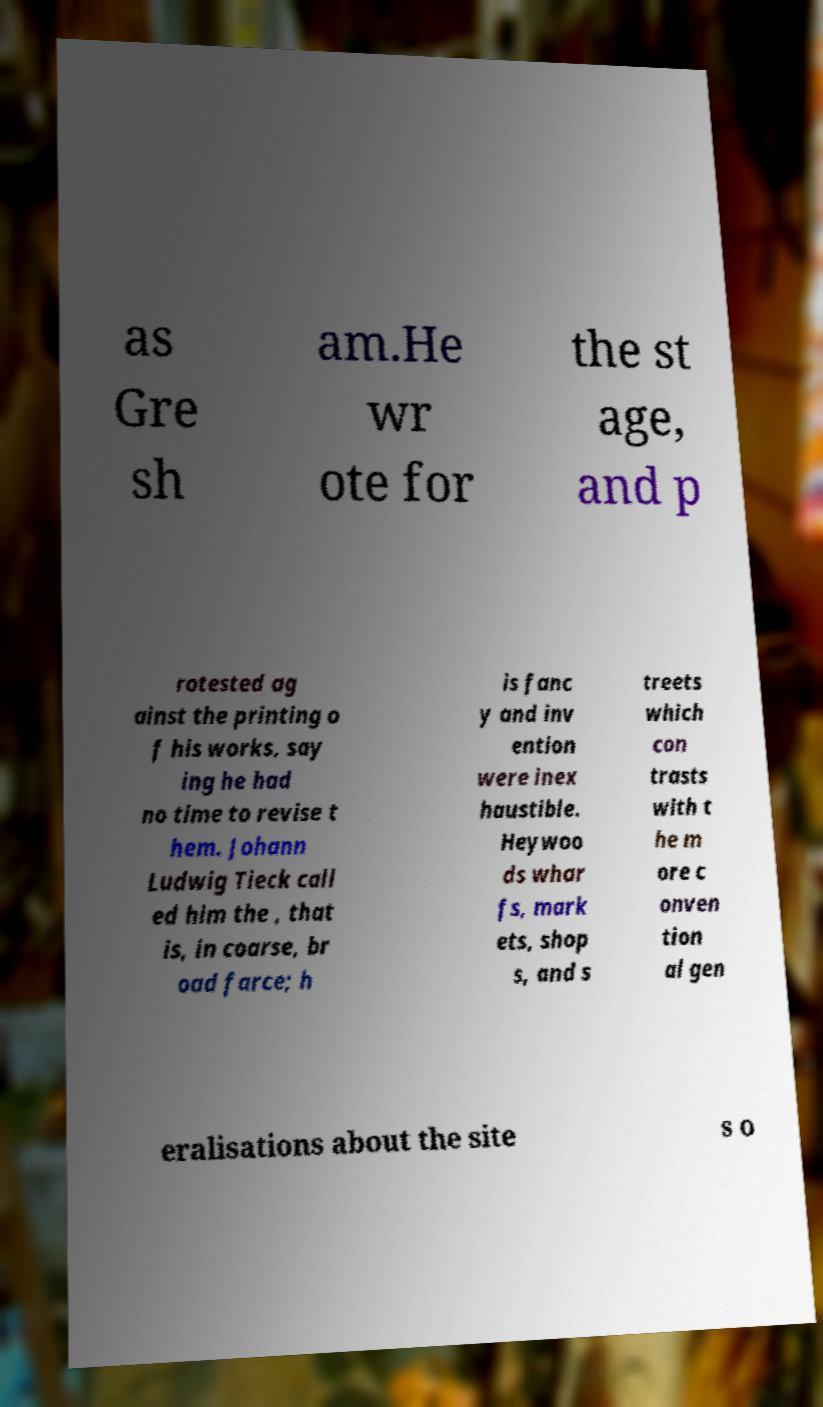Could you extract and type out the text from this image? as Gre sh am.He wr ote for the st age, and p rotested ag ainst the printing o f his works, say ing he had no time to revise t hem. Johann Ludwig Tieck call ed him the , that is, in coarse, br oad farce; h is fanc y and inv ention were inex haustible. Heywoo ds whar fs, mark ets, shop s, and s treets which con trasts with t he m ore c onven tion al gen eralisations about the site s o 